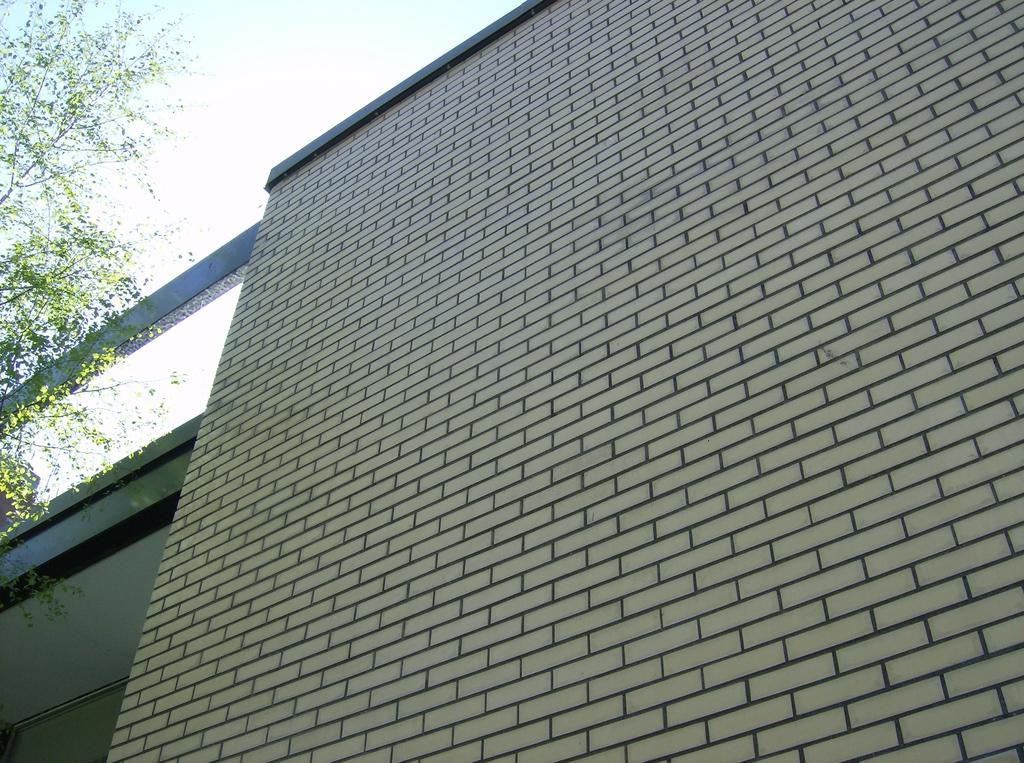What type of structure is present in the image? There is a building in the image. What natural element can be seen in the image? There is a tree in the image. What is visible in the background of the image? The sky is visible in the image. How many lines can be seen on the donkey in the image? There is no donkey present in the image, so it is not possible to determine the number of lines on a donkey. 